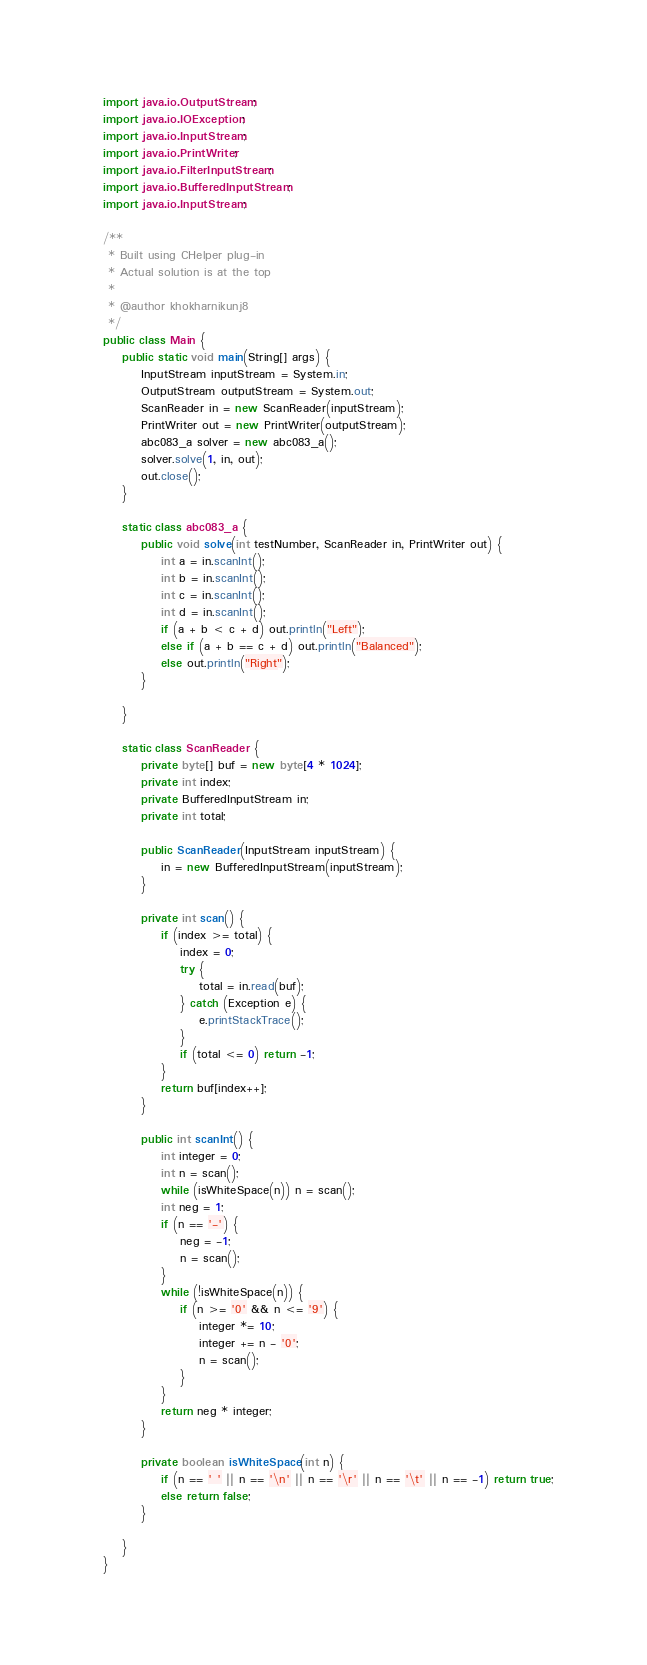<code> <loc_0><loc_0><loc_500><loc_500><_Java_>import java.io.OutputStream;
import java.io.IOException;
import java.io.InputStream;
import java.io.PrintWriter;
import java.io.FilterInputStream;
import java.io.BufferedInputStream;
import java.io.InputStream;

/**
 * Built using CHelper plug-in
 * Actual solution is at the top
 *
 * @author khokharnikunj8
 */
public class Main {
    public static void main(String[] args) {
        InputStream inputStream = System.in;
        OutputStream outputStream = System.out;
        ScanReader in = new ScanReader(inputStream);
        PrintWriter out = new PrintWriter(outputStream);
        abc083_a solver = new abc083_a();
        solver.solve(1, in, out);
        out.close();
    }

    static class abc083_a {
        public void solve(int testNumber, ScanReader in, PrintWriter out) {
            int a = in.scanInt();
            int b = in.scanInt();
            int c = in.scanInt();
            int d = in.scanInt();
            if (a + b < c + d) out.println("Left");
            else if (a + b == c + d) out.println("Balanced");
            else out.println("Right");
        }

    }

    static class ScanReader {
        private byte[] buf = new byte[4 * 1024];
        private int index;
        private BufferedInputStream in;
        private int total;

        public ScanReader(InputStream inputStream) {
            in = new BufferedInputStream(inputStream);
        }

        private int scan() {
            if (index >= total) {
                index = 0;
                try {
                    total = in.read(buf);
                } catch (Exception e) {
                    e.printStackTrace();
                }
                if (total <= 0) return -1;
            }
            return buf[index++];
        }

        public int scanInt() {
            int integer = 0;
            int n = scan();
            while (isWhiteSpace(n)) n = scan();
            int neg = 1;
            if (n == '-') {
                neg = -1;
                n = scan();
            }
            while (!isWhiteSpace(n)) {
                if (n >= '0' && n <= '9') {
                    integer *= 10;
                    integer += n - '0';
                    n = scan();
                }
            }
            return neg * integer;
        }

        private boolean isWhiteSpace(int n) {
            if (n == ' ' || n == '\n' || n == '\r' || n == '\t' || n == -1) return true;
            else return false;
        }

    }
}

</code> 